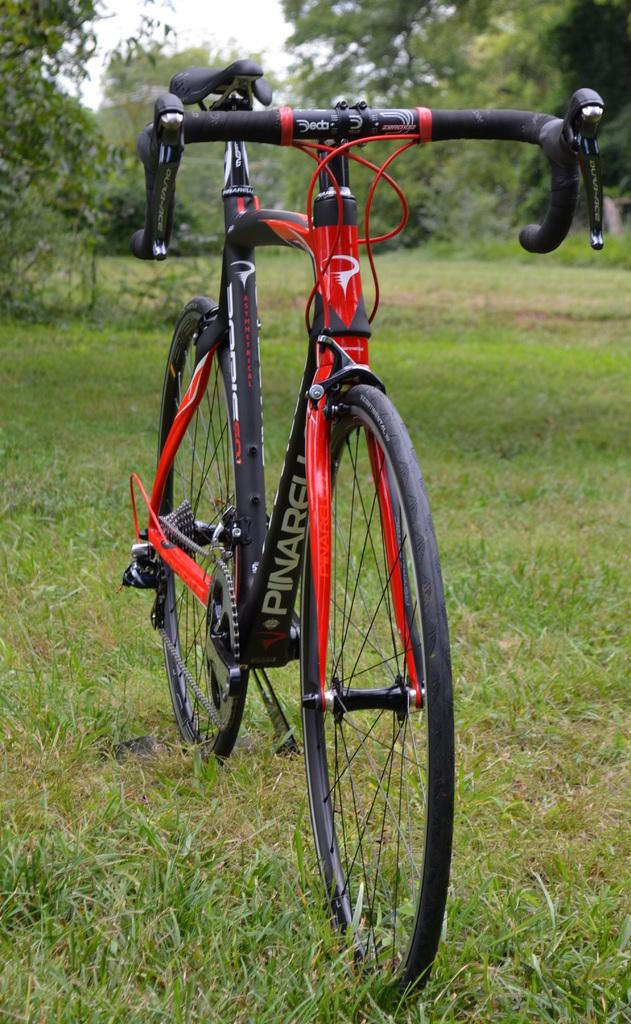What is the main object in the center of the image? There is a cycle in the center of the image. What type of terrain is visible at the bottom of the image? There is grass at the bottom of the image. What can be seen in the distance in the image? There are trees in the background of the image. How many friends are sitting on the cycle in the image? There are no friends visible on the cycle in the image; only the cycle itself is present. 